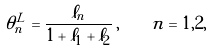<formula> <loc_0><loc_0><loc_500><loc_500>\theta _ { n } ^ { L } = \frac { \ell _ { n } } { 1 + \ell _ { 1 } + \ell _ { 2 } } \, , \quad n = 1 , 2 ,</formula> 